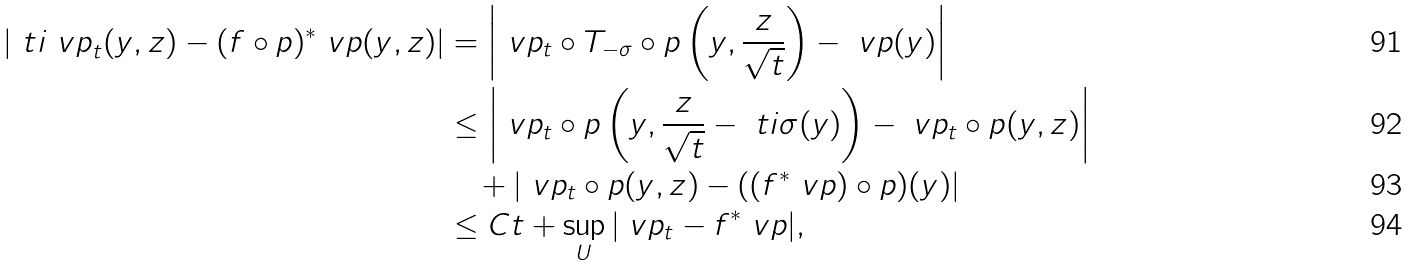Convert formula to latex. <formula><loc_0><loc_0><loc_500><loc_500>| \ t i { \ v p } _ { t } ( y , z ) - ( f \circ p ) ^ { * } \ v p ( y , z ) | & = \left | \ v p _ { t } \circ T _ { - \sigma } \circ p \left ( y , \frac { z } { \sqrt { t } } \right ) - \ v p ( y ) \right | \\ & \leq \left | \ v p _ { t } \circ p \left ( y , \frac { z } { \sqrt { t } } - \ t i { \sigma } ( y ) \right ) - \ v p _ { t } \circ p ( y , z ) \right | \\ & \quad + | \ v p _ { t } \circ p ( y , z ) - ( ( f ^ { * } \ v p ) \circ p ) ( y ) | \\ & \leq C t + \sup _ { U } | \ v p _ { t } - f ^ { * } \ v p | ,</formula> 